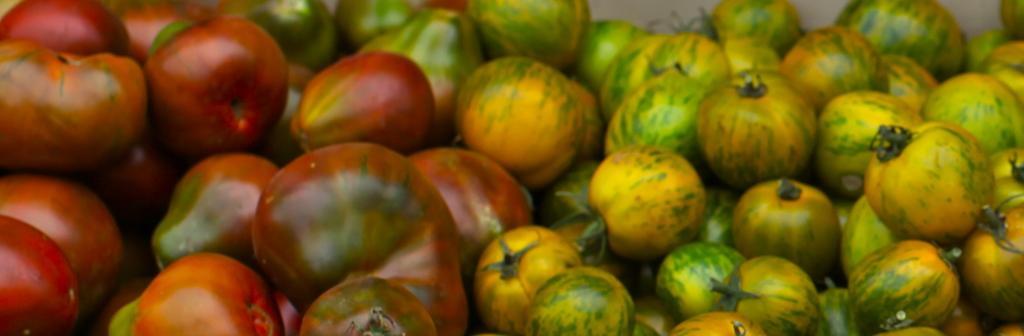In one or two sentences, can you explain what this image depicts? In the center of the image we can see tomatoes, which are in green, yellow and red color. 